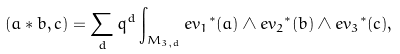<formula> <loc_0><loc_0><loc_500><loc_500>( a * b , c ) = \sum _ { d } { q ^ { d } } \int _ { M _ { 3 , d } } { { e v _ { 1 } } ^ { * } } ( a ) \wedge { { e v _ { 2 } } ^ { * } } ( b ) \wedge { { e v _ { 3 } } ^ { * } } ( c ) ,</formula> 